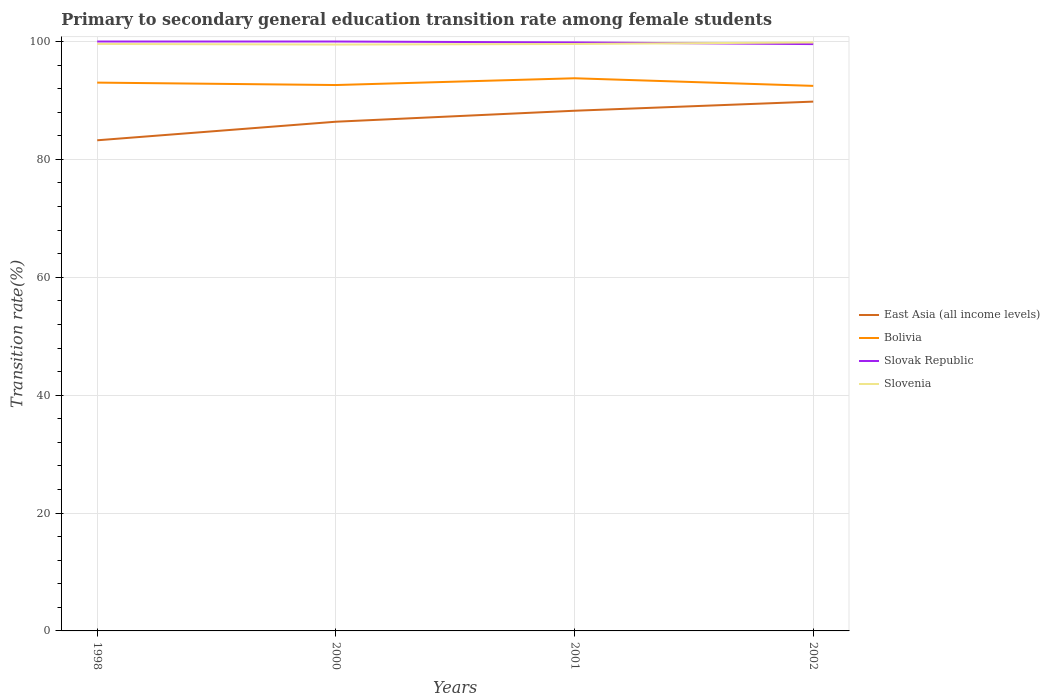Is the number of lines equal to the number of legend labels?
Offer a terse response. Yes. Across all years, what is the maximum transition rate in Bolivia?
Ensure brevity in your answer.  92.47. In which year was the transition rate in Bolivia maximum?
Your answer should be very brief. 2002. What is the total transition rate in East Asia (all income levels) in the graph?
Give a very brief answer. -3.41. What is the difference between the highest and the second highest transition rate in Slovenia?
Give a very brief answer. 0.36. Is the transition rate in Bolivia strictly greater than the transition rate in Slovak Republic over the years?
Provide a short and direct response. Yes. How many years are there in the graph?
Make the answer very short. 4. What is the difference between two consecutive major ticks on the Y-axis?
Make the answer very short. 20. Does the graph contain grids?
Offer a terse response. Yes. Where does the legend appear in the graph?
Give a very brief answer. Center right. How many legend labels are there?
Your response must be concise. 4. What is the title of the graph?
Give a very brief answer. Primary to secondary general education transition rate among female students. What is the label or title of the Y-axis?
Offer a terse response. Transition rate(%). What is the Transition rate(%) of East Asia (all income levels) in 1998?
Provide a succinct answer. 83.24. What is the Transition rate(%) of Bolivia in 1998?
Provide a short and direct response. 93.03. What is the Transition rate(%) of Slovak Republic in 1998?
Your answer should be very brief. 100. What is the Transition rate(%) of Slovenia in 1998?
Offer a terse response. 99.59. What is the Transition rate(%) in East Asia (all income levels) in 2000?
Keep it short and to the point. 86.39. What is the Transition rate(%) of Bolivia in 2000?
Give a very brief answer. 92.62. What is the Transition rate(%) of Slovak Republic in 2000?
Your response must be concise. 100. What is the Transition rate(%) of Slovenia in 2000?
Your answer should be compact. 99.48. What is the Transition rate(%) of East Asia (all income levels) in 2001?
Provide a succinct answer. 88.26. What is the Transition rate(%) of Bolivia in 2001?
Ensure brevity in your answer.  93.76. What is the Transition rate(%) of Slovak Republic in 2001?
Offer a terse response. 99.84. What is the Transition rate(%) of Slovenia in 2001?
Provide a short and direct response. 99.58. What is the Transition rate(%) in East Asia (all income levels) in 2002?
Ensure brevity in your answer.  89.8. What is the Transition rate(%) in Bolivia in 2002?
Keep it short and to the point. 92.47. What is the Transition rate(%) in Slovak Republic in 2002?
Your answer should be very brief. 99.56. What is the Transition rate(%) of Slovenia in 2002?
Offer a terse response. 99.84. Across all years, what is the maximum Transition rate(%) of East Asia (all income levels)?
Provide a short and direct response. 89.8. Across all years, what is the maximum Transition rate(%) of Bolivia?
Offer a very short reply. 93.76. Across all years, what is the maximum Transition rate(%) of Slovak Republic?
Provide a short and direct response. 100. Across all years, what is the maximum Transition rate(%) in Slovenia?
Make the answer very short. 99.84. Across all years, what is the minimum Transition rate(%) in East Asia (all income levels)?
Your response must be concise. 83.24. Across all years, what is the minimum Transition rate(%) of Bolivia?
Provide a short and direct response. 92.47. Across all years, what is the minimum Transition rate(%) of Slovak Republic?
Your answer should be compact. 99.56. Across all years, what is the minimum Transition rate(%) in Slovenia?
Give a very brief answer. 99.48. What is the total Transition rate(%) of East Asia (all income levels) in the graph?
Provide a succinct answer. 347.69. What is the total Transition rate(%) of Bolivia in the graph?
Make the answer very short. 371.88. What is the total Transition rate(%) in Slovak Republic in the graph?
Your answer should be compact. 399.41. What is the total Transition rate(%) of Slovenia in the graph?
Your answer should be compact. 398.5. What is the difference between the Transition rate(%) of East Asia (all income levels) in 1998 and that in 2000?
Your answer should be very brief. -3.15. What is the difference between the Transition rate(%) in Bolivia in 1998 and that in 2000?
Provide a short and direct response. 0.41. What is the difference between the Transition rate(%) in Slovenia in 1998 and that in 2000?
Provide a succinct answer. 0.11. What is the difference between the Transition rate(%) in East Asia (all income levels) in 1998 and that in 2001?
Give a very brief answer. -5.01. What is the difference between the Transition rate(%) in Bolivia in 1998 and that in 2001?
Your answer should be compact. -0.74. What is the difference between the Transition rate(%) in Slovak Republic in 1998 and that in 2001?
Ensure brevity in your answer.  0.16. What is the difference between the Transition rate(%) in Slovenia in 1998 and that in 2001?
Your answer should be compact. 0.01. What is the difference between the Transition rate(%) of East Asia (all income levels) in 1998 and that in 2002?
Ensure brevity in your answer.  -6.56. What is the difference between the Transition rate(%) of Bolivia in 1998 and that in 2002?
Offer a very short reply. 0.55. What is the difference between the Transition rate(%) in Slovak Republic in 1998 and that in 2002?
Offer a very short reply. 0.44. What is the difference between the Transition rate(%) of Slovenia in 1998 and that in 2002?
Offer a terse response. -0.25. What is the difference between the Transition rate(%) in East Asia (all income levels) in 2000 and that in 2001?
Give a very brief answer. -1.86. What is the difference between the Transition rate(%) in Bolivia in 2000 and that in 2001?
Make the answer very short. -1.15. What is the difference between the Transition rate(%) in Slovak Republic in 2000 and that in 2001?
Provide a short and direct response. 0.16. What is the difference between the Transition rate(%) in Slovenia in 2000 and that in 2001?
Your response must be concise. -0.1. What is the difference between the Transition rate(%) of East Asia (all income levels) in 2000 and that in 2002?
Make the answer very short. -3.41. What is the difference between the Transition rate(%) in Bolivia in 2000 and that in 2002?
Your response must be concise. 0.14. What is the difference between the Transition rate(%) in Slovak Republic in 2000 and that in 2002?
Make the answer very short. 0.44. What is the difference between the Transition rate(%) of Slovenia in 2000 and that in 2002?
Provide a succinct answer. -0.36. What is the difference between the Transition rate(%) in East Asia (all income levels) in 2001 and that in 2002?
Provide a short and direct response. -1.55. What is the difference between the Transition rate(%) of Bolivia in 2001 and that in 2002?
Provide a succinct answer. 1.29. What is the difference between the Transition rate(%) of Slovak Republic in 2001 and that in 2002?
Keep it short and to the point. 0.28. What is the difference between the Transition rate(%) of Slovenia in 2001 and that in 2002?
Offer a very short reply. -0.26. What is the difference between the Transition rate(%) in East Asia (all income levels) in 1998 and the Transition rate(%) in Bolivia in 2000?
Provide a succinct answer. -9.38. What is the difference between the Transition rate(%) of East Asia (all income levels) in 1998 and the Transition rate(%) of Slovak Republic in 2000?
Provide a short and direct response. -16.76. What is the difference between the Transition rate(%) of East Asia (all income levels) in 1998 and the Transition rate(%) of Slovenia in 2000?
Offer a very short reply. -16.24. What is the difference between the Transition rate(%) in Bolivia in 1998 and the Transition rate(%) in Slovak Republic in 2000?
Your answer should be compact. -6.97. What is the difference between the Transition rate(%) of Bolivia in 1998 and the Transition rate(%) of Slovenia in 2000?
Keep it short and to the point. -6.45. What is the difference between the Transition rate(%) of Slovak Republic in 1998 and the Transition rate(%) of Slovenia in 2000?
Offer a very short reply. 0.52. What is the difference between the Transition rate(%) of East Asia (all income levels) in 1998 and the Transition rate(%) of Bolivia in 2001?
Your answer should be very brief. -10.52. What is the difference between the Transition rate(%) in East Asia (all income levels) in 1998 and the Transition rate(%) in Slovak Republic in 2001?
Keep it short and to the point. -16.6. What is the difference between the Transition rate(%) in East Asia (all income levels) in 1998 and the Transition rate(%) in Slovenia in 2001?
Keep it short and to the point. -16.34. What is the difference between the Transition rate(%) of Bolivia in 1998 and the Transition rate(%) of Slovak Republic in 2001?
Provide a succinct answer. -6.82. What is the difference between the Transition rate(%) of Bolivia in 1998 and the Transition rate(%) of Slovenia in 2001?
Your response must be concise. -6.55. What is the difference between the Transition rate(%) in Slovak Republic in 1998 and the Transition rate(%) in Slovenia in 2001?
Your answer should be compact. 0.42. What is the difference between the Transition rate(%) in East Asia (all income levels) in 1998 and the Transition rate(%) in Bolivia in 2002?
Make the answer very short. -9.23. What is the difference between the Transition rate(%) of East Asia (all income levels) in 1998 and the Transition rate(%) of Slovak Republic in 2002?
Keep it short and to the point. -16.32. What is the difference between the Transition rate(%) in East Asia (all income levels) in 1998 and the Transition rate(%) in Slovenia in 2002?
Your answer should be compact. -16.6. What is the difference between the Transition rate(%) in Bolivia in 1998 and the Transition rate(%) in Slovak Republic in 2002?
Your answer should be compact. -6.54. What is the difference between the Transition rate(%) of Bolivia in 1998 and the Transition rate(%) of Slovenia in 2002?
Your answer should be very brief. -6.82. What is the difference between the Transition rate(%) of Slovak Republic in 1998 and the Transition rate(%) of Slovenia in 2002?
Offer a very short reply. 0.16. What is the difference between the Transition rate(%) in East Asia (all income levels) in 2000 and the Transition rate(%) in Bolivia in 2001?
Your answer should be very brief. -7.37. What is the difference between the Transition rate(%) in East Asia (all income levels) in 2000 and the Transition rate(%) in Slovak Republic in 2001?
Your answer should be very brief. -13.45. What is the difference between the Transition rate(%) of East Asia (all income levels) in 2000 and the Transition rate(%) of Slovenia in 2001?
Give a very brief answer. -13.19. What is the difference between the Transition rate(%) in Bolivia in 2000 and the Transition rate(%) in Slovak Republic in 2001?
Offer a terse response. -7.23. What is the difference between the Transition rate(%) of Bolivia in 2000 and the Transition rate(%) of Slovenia in 2001?
Make the answer very short. -6.96. What is the difference between the Transition rate(%) in Slovak Republic in 2000 and the Transition rate(%) in Slovenia in 2001?
Your answer should be compact. 0.42. What is the difference between the Transition rate(%) of East Asia (all income levels) in 2000 and the Transition rate(%) of Bolivia in 2002?
Your answer should be compact. -6.08. What is the difference between the Transition rate(%) in East Asia (all income levels) in 2000 and the Transition rate(%) in Slovak Republic in 2002?
Provide a succinct answer. -13.17. What is the difference between the Transition rate(%) in East Asia (all income levels) in 2000 and the Transition rate(%) in Slovenia in 2002?
Your response must be concise. -13.45. What is the difference between the Transition rate(%) in Bolivia in 2000 and the Transition rate(%) in Slovak Republic in 2002?
Provide a short and direct response. -6.95. What is the difference between the Transition rate(%) in Bolivia in 2000 and the Transition rate(%) in Slovenia in 2002?
Keep it short and to the point. -7.23. What is the difference between the Transition rate(%) in Slovak Republic in 2000 and the Transition rate(%) in Slovenia in 2002?
Give a very brief answer. 0.16. What is the difference between the Transition rate(%) of East Asia (all income levels) in 2001 and the Transition rate(%) of Bolivia in 2002?
Provide a succinct answer. -4.22. What is the difference between the Transition rate(%) of East Asia (all income levels) in 2001 and the Transition rate(%) of Slovak Republic in 2002?
Make the answer very short. -11.31. What is the difference between the Transition rate(%) in East Asia (all income levels) in 2001 and the Transition rate(%) in Slovenia in 2002?
Make the answer very short. -11.59. What is the difference between the Transition rate(%) of Bolivia in 2001 and the Transition rate(%) of Slovak Republic in 2002?
Provide a succinct answer. -5.8. What is the difference between the Transition rate(%) of Bolivia in 2001 and the Transition rate(%) of Slovenia in 2002?
Offer a terse response. -6.08. What is the difference between the Transition rate(%) in Slovak Republic in 2001 and the Transition rate(%) in Slovenia in 2002?
Offer a very short reply. 0. What is the average Transition rate(%) of East Asia (all income levels) per year?
Provide a succinct answer. 86.92. What is the average Transition rate(%) in Bolivia per year?
Provide a short and direct response. 92.97. What is the average Transition rate(%) in Slovak Republic per year?
Offer a terse response. 99.85. What is the average Transition rate(%) of Slovenia per year?
Your answer should be very brief. 99.62. In the year 1998, what is the difference between the Transition rate(%) of East Asia (all income levels) and Transition rate(%) of Bolivia?
Provide a succinct answer. -9.79. In the year 1998, what is the difference between the Transition rate(%) of East Asia (all income levels) and Transition rate(%) of Slovak Republic?
Keep it short and to the point. -16.76. In the year 1998, what is the difference between the Transition rate(%) of East Asia (all income levels) and Transition rate(%) of Slovenia?
Make the answer very short. -16.35. In the year 1998, what is the difference between the Transition rate(%) in Bolivia and Transition rate(%) in Slovak Republic?
Your answer should be very brief. -6.97. In the year 1998, what is the difference between the Transition rate(%) of Bolivia and Transition rate(%) of Slovenia?
Keep it short and to the point. -6.56. In the year 1998, what is the difference between the Transition rate(%) of Slovak Republic and Transition rate(%) of Slovenia?
Your answer should be very brief. 0.41. In the year 2000, what is the difference between the Transition rate(%) in East Asia (all income levels) and Transition rate(%) in Bolivia?
Keep it short and to the point. -6.23. In the year 2000, what is the difference between the Transition rate(%) of East Asia (all income levels) and Transition rate(%) of Slovak Republic?
Offer a terse response. -13.61. In the year 2000, what is the difference between the Transition rate(%) of East Asia (all income levels) and Transition rate(%) of Slovenia?
Ensure brevity in your answer.  -13.09. In the year 2000, what is the difference between the Transition rate(%) in Bolivia and Transition rate(%) in Slovak Republic?
Your answer should be compact. -7.38. In the year 2000, what is the difference between the Transition rate(%) in Bolivia and Transition rate(%) in Slovenia?
Ensure brevity in your answer.  -6.87. In the year 2000, what is the difference between the Transition rate(%) of Slovak Republic and Transition rate(%) of Slovenia?
Give a very brief answer. 0.52. In the year 2001, what is the difference between the Transition rate(%) in East Asia (all income levels) and Transition rate(%) in Bolivia?
Your answer should be compact. -5.51. In the year 2001, what is the difference between the Transition rate(%) in East Asia (all income levels) and Transition rate(%) in Slovak Republic?
Offer a terse response. -11.59. In the year 2001, what is the difference between the Transition rate(%) of East Asia (all income levels) and Transition rate(%) of Slovenia?
Ensure brevity in your answer.  -11.33. In the year 2001, what is the difference between the Transition rate(%) of Bolivia and Transition rate(%) of Slovak Republic?
Make the answer very short. -6.08. In the year 2001, what is the difference between the Transition rate(%) of Bolivia and Transition rate(%) of Slovenia?
Offer a terse response. -5.82. In the year 2001, what is the difference between the Transition rate(%) of Slovak Republic and Transition rate(%) of Slovenia?
Offer a terse response. 0.26. In the year 2002, what is the difference between the Transition rate(%) in East Asia (all income levels) and Transition rate(%) in Bolivia?
Your response must be concise. -2.67. In the year 2002, what is the difference between the Transition rate(%) of East Asia (all income levels) and Transition rate(%) of Slovak Republic?
Your answer should be compact. -9.76. In the year 2002, what is the difference between the Transition rate(%) in East Asia (all income levels) and Transition rate(%) in Slovenia?
Give a very brief answer. -10.04. In the year 2002, what is the difference between the Transition rate(%) in Bolivia and Transition rate(%) in Slovak Republic?
Provide a succinct answer. -7.09. In the year 2002, what is the difference between the Transition rate(%) in Bolivia and Transition rate(%) in Slovenia?
Provide a short and direct response. -7.37. In the year 2002, what is the difference between the Transition rate(%) in Slovak Republic and Transition rate(%) in Slovenia?
Your response must be concise. -0.28. What is the ratio of the Transition rate(%) in East Asia (all income levels) in 1998 to that in 2000?
Provide a short and direct response. 0.96. What is the ratio of the Transition rate(%) in Slovak Republic in 1998 to that in 2000?
Give a very brief answer. 1. What is the ratio of the Transition rate(%) of Slovenia in 1998 to that in 2000?
Provide a succinct answer. 1. What is the ratio of the Transition rate(%) of East Asia (all income levels) in 1998 to that in 2001?
Offer a very short reply. 0.94. What is the ratio of the Transition rate(%) of East Asia (all income levels) in 1998 to that in 2002?
Your answer should be compact. 0.93. What is the ratio of the Transition rate(%) in Bolivia in 1998 to that in 2002?
Offer a very short reply. 1.01. What is the ratio of the Transition rate(%) in East Asia (all income levels) in 2000 to that in 2001?
Your answer should be very brief. 0.98. What is the ratio of the Transition rate(%) in Bolivia in 2000 to that in 2001?
Keep it short and to the point. 0.99. What is the ratio of the Transition rate(%) of Slovenia in 2000 to that in 2001?
Offer a very short reply. 1. What is the ratio of the Transition rate(%) in East Asia (all income levels) in 2000 to that in 2002?
Provide a short and direct response. 0.96. What is the ratio of the Transition rate(%) in Slovenia in 2000 to that in 2002?
Keep it short and to the point. 1. What is the ratio of the Transition rate(%) in East Asia (all income levels) in 2001 to that in 2002?
Offer a terse response. 0.98. What is the ratio of the Transition rate(%) of Slovak Republic in 2001 to that in 2002?
Offer a terse response. 1. What is the ratio of the Transition rate(%) in Slovenia in 2001 to that in 2002?
Provide a short and direct response. 1. What is the difference between the highest and the second highest Transition rate(%) in East Asia (all income levels)?
Provide a short and direct response. 1.55. What is the difference between the highest and the second highest Transition rate(%) of Bolivia?
Provide a short and direct response. 0.74. What is the difference between the highest and the second highest Transition rate(%) of Slovak Republic?
Offer a very short reply. 0. What is the difference between the highest and the second highest Transition rate(%) in Slovenia?
Keep it short and to the point. 0.25. What is the difference between the highest and the lowest Transition rate(%) in East Asia (all income levels)?
Offer a terse response. 6.56. What is the difference between the highest and the lowest Transition rate(%) in Bolivia?
Offer a very short reply. 1.29. What is the difference between the highest and the lowest Transition rate(%) of Slovak Republic?
Offer a very short reply. 0.44. What is the difference between the highest and the lowest Transition rate(%) of Slovenia?
Provide a succinct answer. 0.36. 